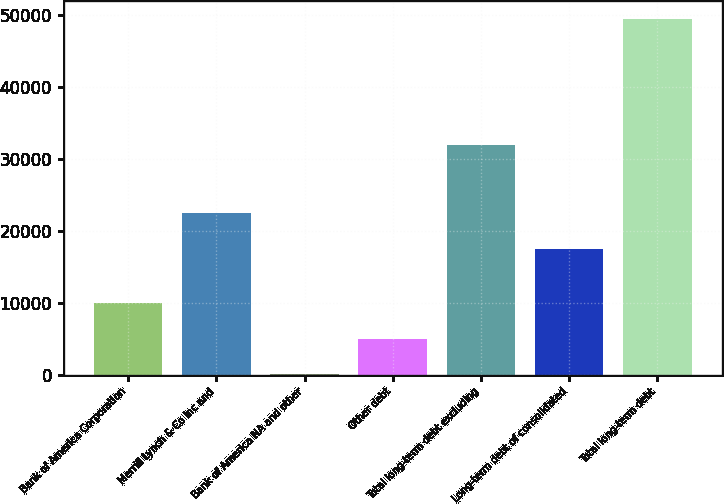<chart> <loc_0><loc_0><loc_500><loc_500><bar_chart><fcel>Bank of America Corporation<fcel>Merrill Lynch & Co Inc and<fcel>Bank of America NA and other<fcel>Other debt<fcel>Total long-term debt excluding<fcel>Long-term debt of consolidated<fcel>Total long-term debt<nl><fcel>9963.9<fcel>22446.9<fcel>86<fcel>5031<fcel>31901<fcel>17514<fcel>49415<nl></chart> 